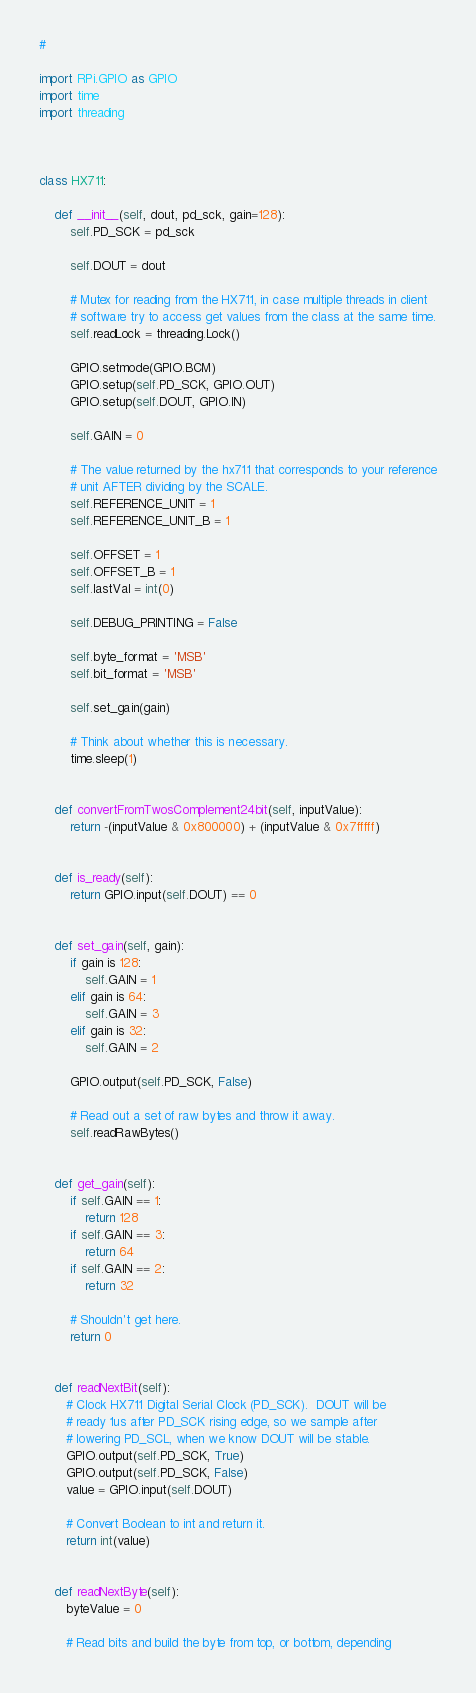<code> <loc_0><loc_0><loc_500><loc_500><_Python_>#

import RPi.GPIO as GPIO
import time
import threading



class HX711:

    def __init__(self, dout, pd_sck, gain=128):
        self.PD_SCK = pd_sck

        self.DOUT = dout

        # Mutex for reading from the HX711, in case multiple threads in client
        # software try to access get values from the class at the same time.
        self.readLock = threading.Lock()
        
        GPIO.setmode(GPIO.BCM)
        GPIO.setup(self.PD_SCK, GPIO.OUT)
        GPIO.setup(self.DOUT, GPIO.IN)

        self.GAIN = 0

        # The value returned by the hx711 that corresponds to your reference
        # unit AFTER dividing by the SCALE.
        self.REFERENCE_UNIT = 1
        self.REFERENCE_UNIT_B = 1

        self.OFFSET = 1
        self.OFFSET_B = 1
        self.lastVal = int(0)

        self.DEBUG_PRINTING = False

        self.byte_format = 'MSB'
        self.bit_format = 'MSB'

        self.set_gain(gain)

        # Think about whether this is necessary.
        time.sleep(1)

        
    def convertFromTwosComplement24bit(self, inputValue):
        return -(inputValue & 0x800000) + (inputValue & 0x7fffff)

    
    def is_ready(self):
        return GPIO.input(self.DOUT) == 0

    
    def set_gain(self, gain):
        if gain is 128:
            self.GAIN = 1
        elif gain is 64:
            self.GAIN = 3
        elif gain is 32:
            self.GAIN = 2

        GPIO.output(self.PD_SCK, False)

        # Read out a set of raw bytes and throw it away.
        self.readRawBytes()

        
    def get_gain(self):
        if self.GAIN == 1:
            return 128
        if self.GAIN == 3:
            return 64
        if self.GAIN == 2:
            return 32

        # Shouldn't get here.
        return 0
        

    def readNextBit(self):
       # Clock HX711 Digital Serial Clock (PD_SCK).  DOUT will be
       # ready 1us after PD_SCK rising edge, so we sample after
       # lowering PD_SCL, when we know DOUT will be stable.
       GPIO.output(self.PD_SCK, True)
       GPIO.output(self.PD_SCK, False)
       value = GPIO.input(self.DOUT)

       # Convert Boolean to int and return it.
       return int(value)


    def readNextByte(self):
       byteValue = 0

       # Read bits and build the byte from top, or bottom, depending</code> 